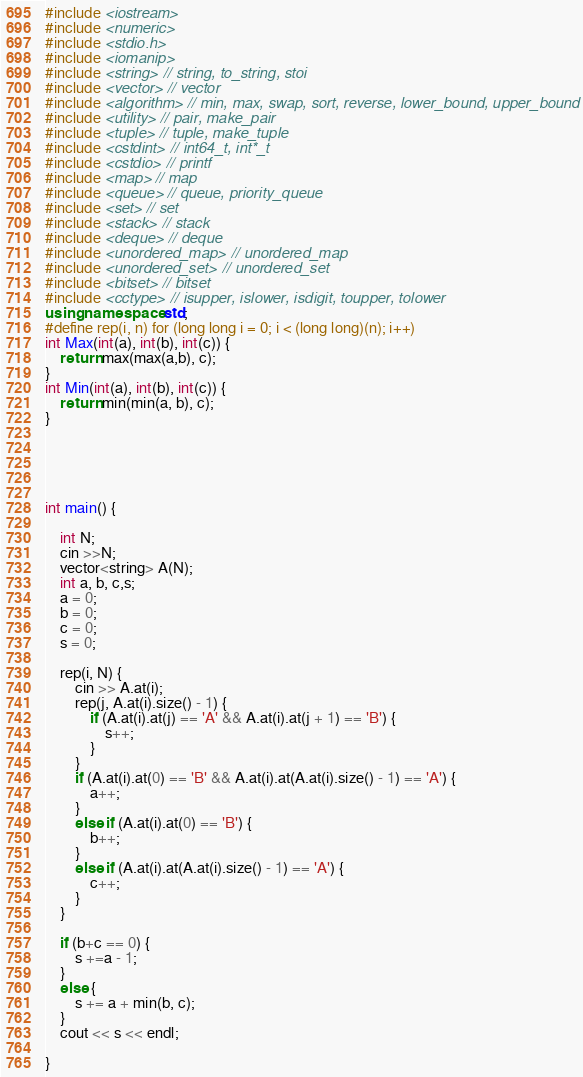<code> <loc_0><loc_0><loc_500><loc_500><_C++_>#include <iostream>
#include <numeric>
#include <stdio.h>
#include <iomanip>
#include <string> // string, to_string, stoi
#include <vector> // vector
#include <algorithm> // min, max, swap, sort, reverse, lower_bound, upper_bound
#include <utility> // pair, make_pair
#include <tuple> // tuple, make_tuple
#include <cstdint> // int64_t, int*_t
#include <cstdio> // printf
#include <map> // map
#include <queue> // queue, priority_queue
#include <set> // set
#include <stack> // stack
#include <deque> // deque
#include <unordered_map> // unordered_map
#include <unordered_set> // unordered_set
#include <bitset> // bitset
#include <cctype> // isupper, islower, isdigit, toupper, tolower
using namespace std;
#define rep(i, n) for (long long i = 0; i < (long long)(n); i++)
int Max(int(a), int(b), int(c)) {
	return max(max(a,b), c);
}
int Min(int(a), int(b), int(c)) {
	return min(min(a, b), c);
}





int main() {
	
	int N;
	cin >>N;
	vector<string> A(N);
	int a, b, c,s;
	a = 0;
	b = 0;
	c = 0;
	s = 0;

	rep(i, N) {
		cin >> A.at(i);
		rep(j, A.at(i).size() - 1) {
			if (A.at(i).at(j) == 'A' && A.at(i).at(j + 1) == 'B') {
				s++;
			}
		}
		if (A.at(i).at(0) == 'B' && A.at(i).at(A.at(i).size() - 1) == 'A') {
			a++;
		}
		else if (A.at(i).at(0) == 'B') {
			b++;
		}
		else if (A.at(i).at(A.at(i).size() - 1) == 'A') {
			c++;
		}
	}

	if (b+c == 0) {
		s +=a - 1;
	}
	else {
		s += a + min(b, c);
	}
	cout << s << endl;

}
</code> 